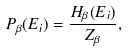Convert formula to latex. <formula><loc_0><loc_0><loc_500><loc_500>P _ { \beta } ( E _ { i } ) = \frac { H _ { \beta } ( E _ { i } ) } { Z _ { \beta } } ,</formula> 